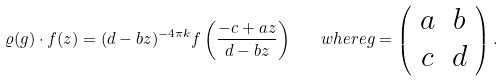Convert formula to latex. <formula><loc_0><loc_0><loc_500><loc_500>\varrho ( g ) \cdot f ( z ) = ( d - b z ) ^ { - 4 \pi k } f \left ( \frac { - c + a z } { d - b z } \right ) \quad w h e r e g = \left ( \begin{array} { c c } a & b \\ c & d \end{array} \right ) .</formula> 